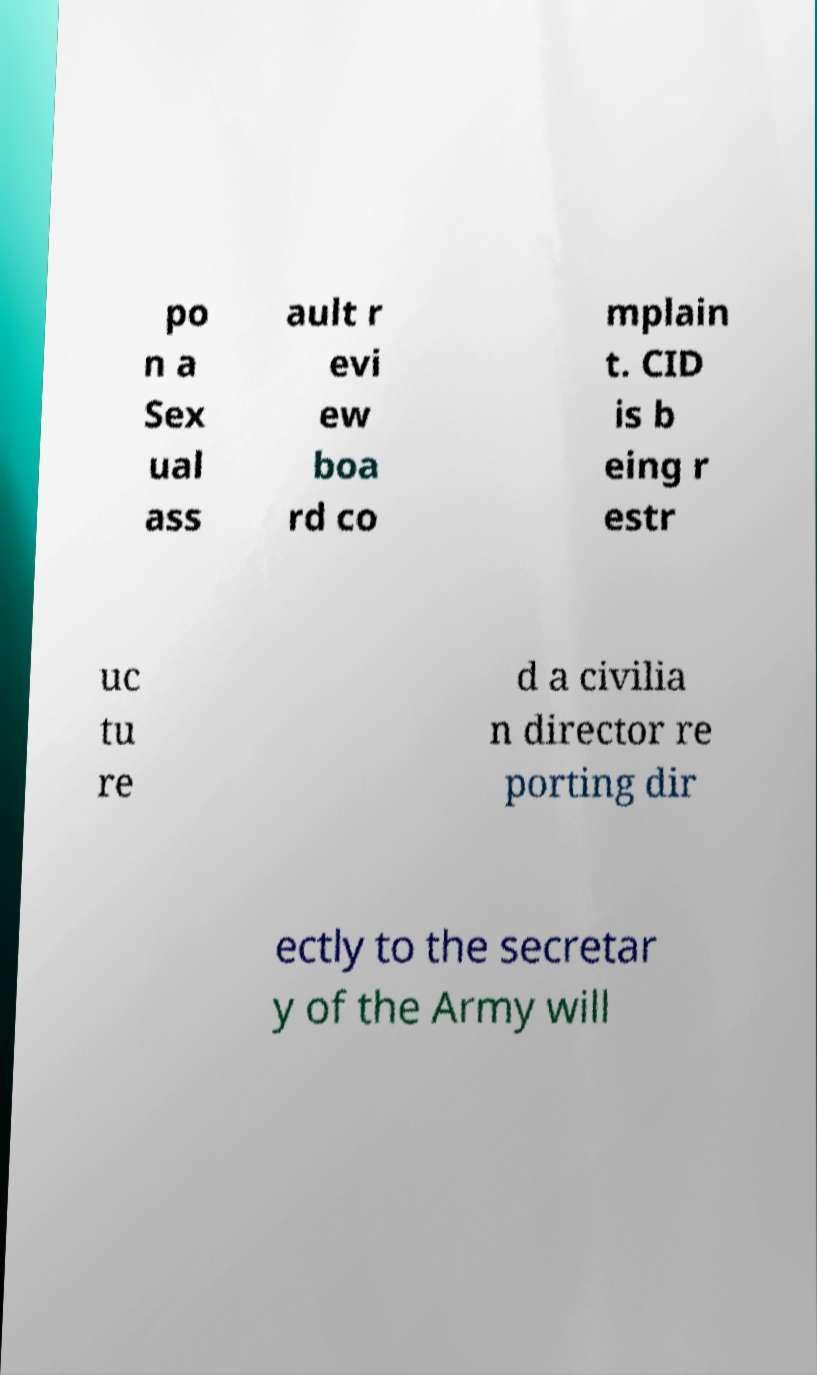What messages or text are displayed in this image? I need them in a readable, typed format. po n a Sex ual ass ault r evi ew boa rd co mplain t. CID is b eing r estr uc tu re d a civilia n director re porting dir ectly to the secretar y of the Army will 